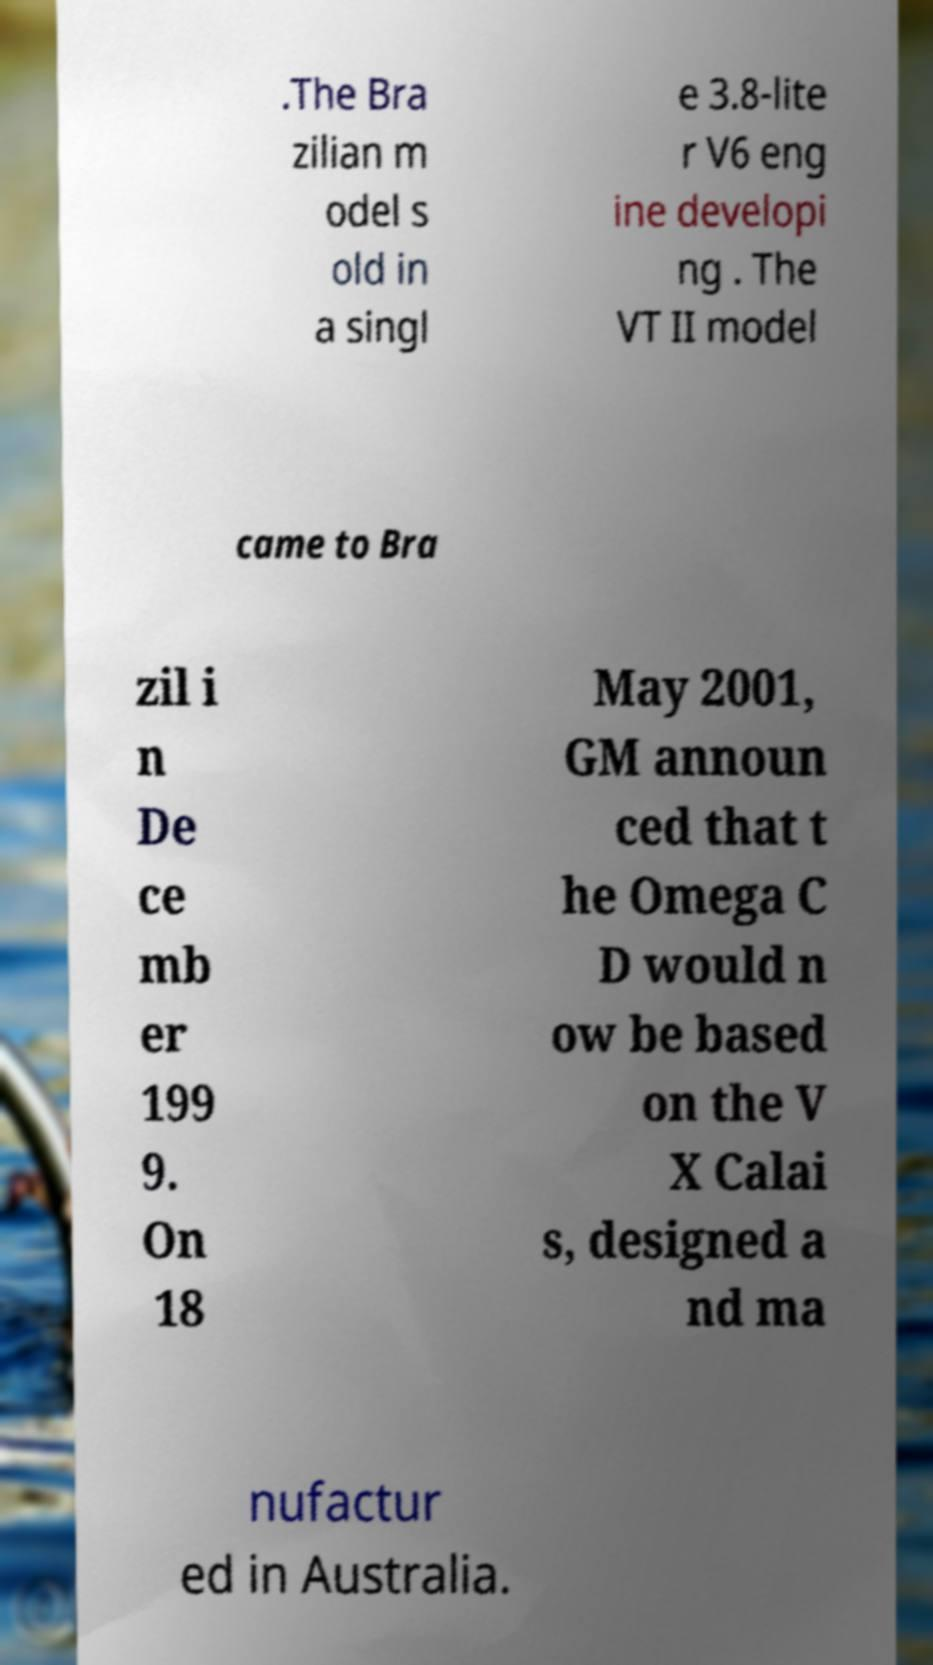Please identify and transcribe the text found in this image. .The Bra zilian m odel s old in a singl e 3.8-lite r V6 eng ine developi ng . The VT II model came to Bra zil i n De ce mb er 199 9. On 18 May 2001, GM announ ced that t he Omega C D would n ow be based on the V X Calai s, designed a nd ma nufactur ed in Australia. 